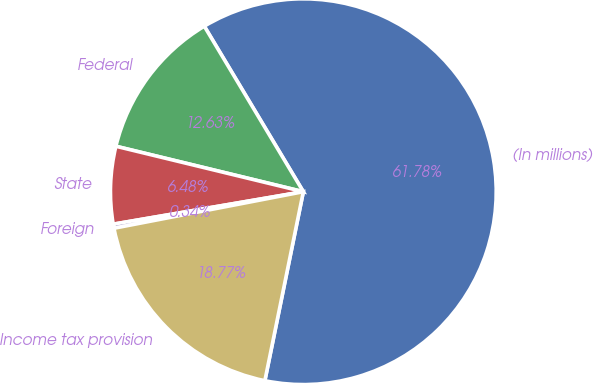Convert chart to OTSL. <chart><loc_0><loc_0><loc_500><loc_500><pie_chart><fcel>(In millions)<fcel>Federal<fcel>State<fcel>Foreign<fcel>Income tax provision<nl><fcel>61.78%<fcel>12.63%<fcel>6.48%<fcel>0.34%<fcel>18.77%<nl></chart> 